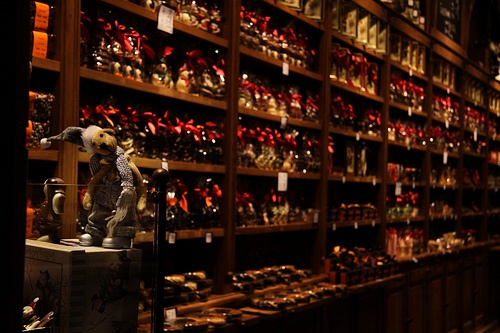Describe the objects in this image and their specific colors. I can see a teddy bear in black, maroon, and olive tones in this image. 